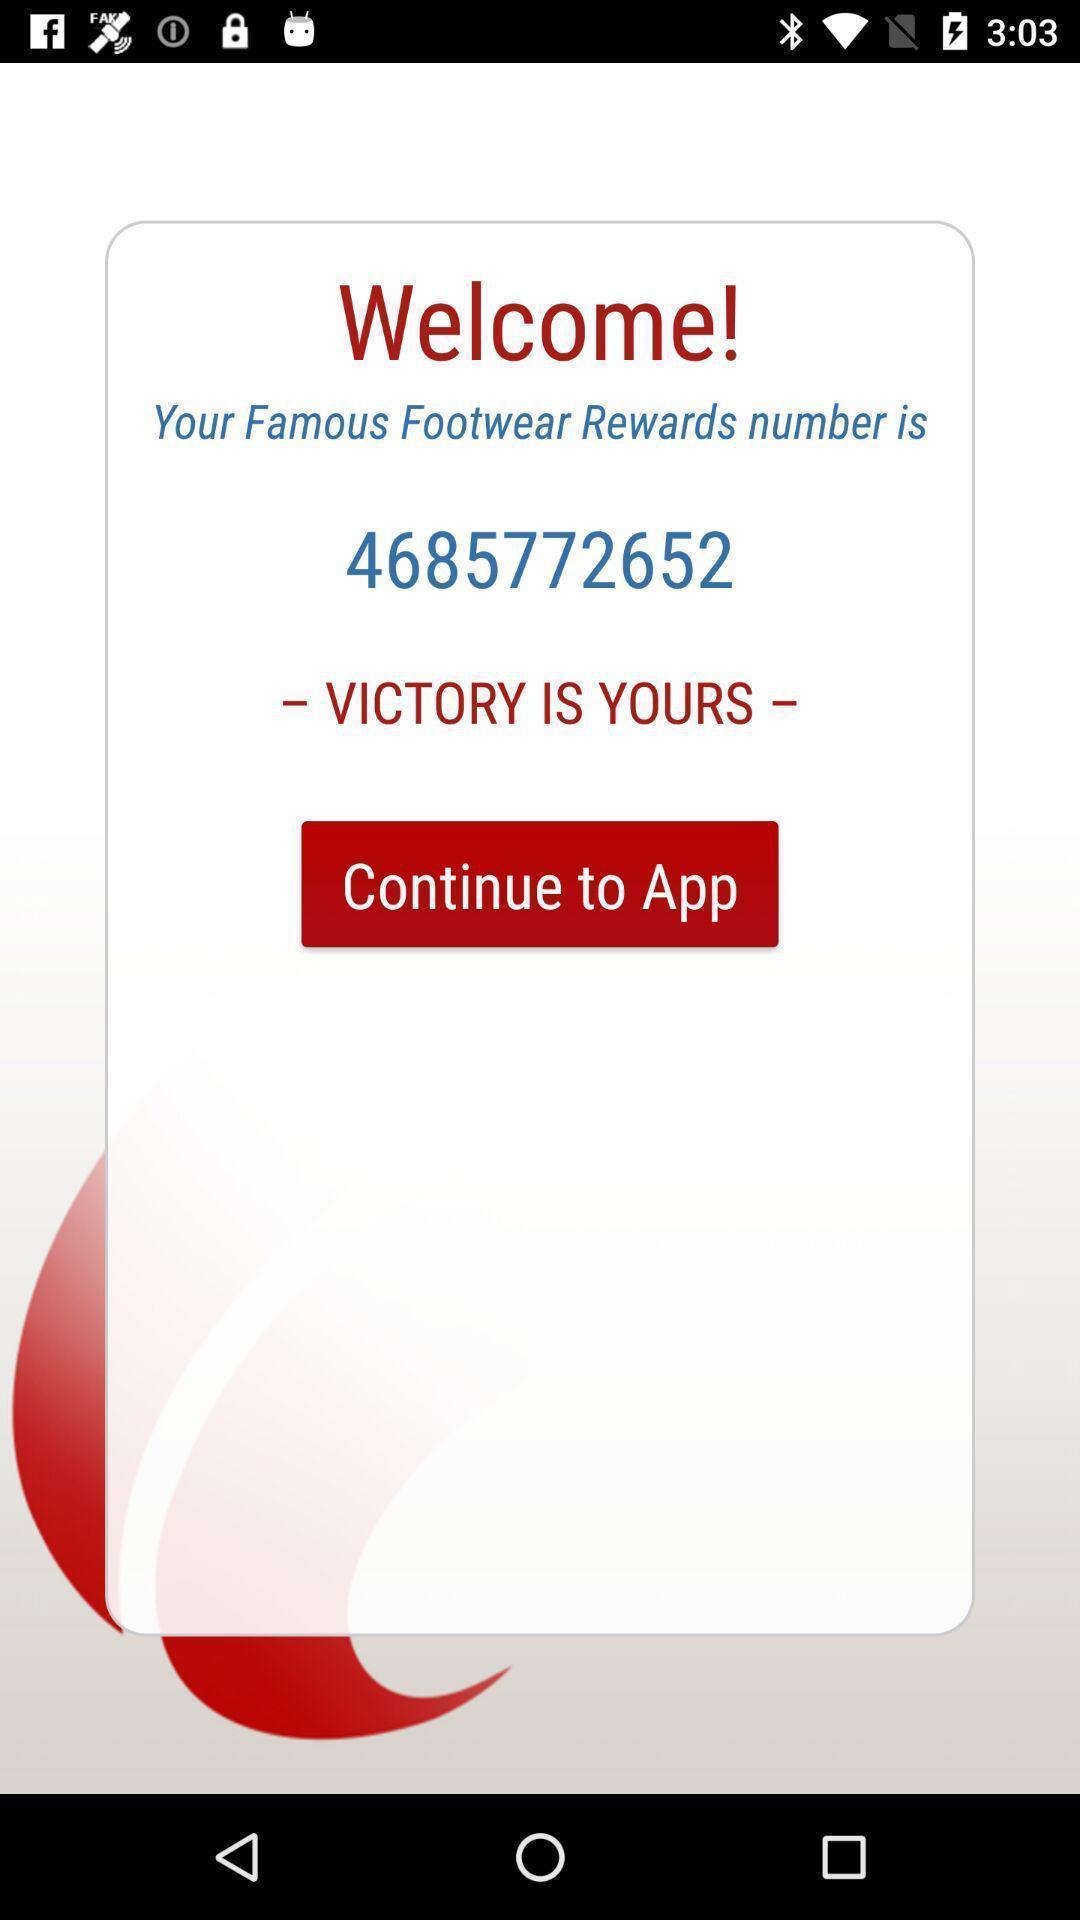Please provide a description for this image. Welcome page. 